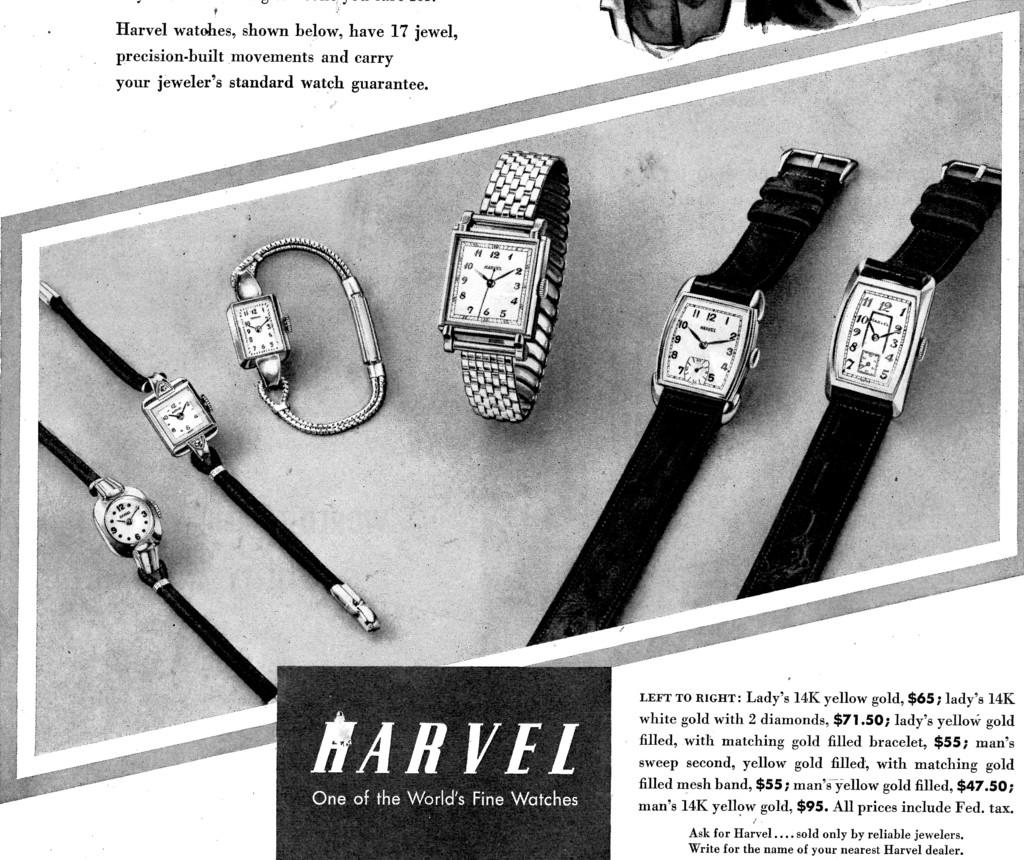Provide a one-sentence caption for the provided image. Six Marvel watches of different shapes and sizes are laid out in this advertisement. 